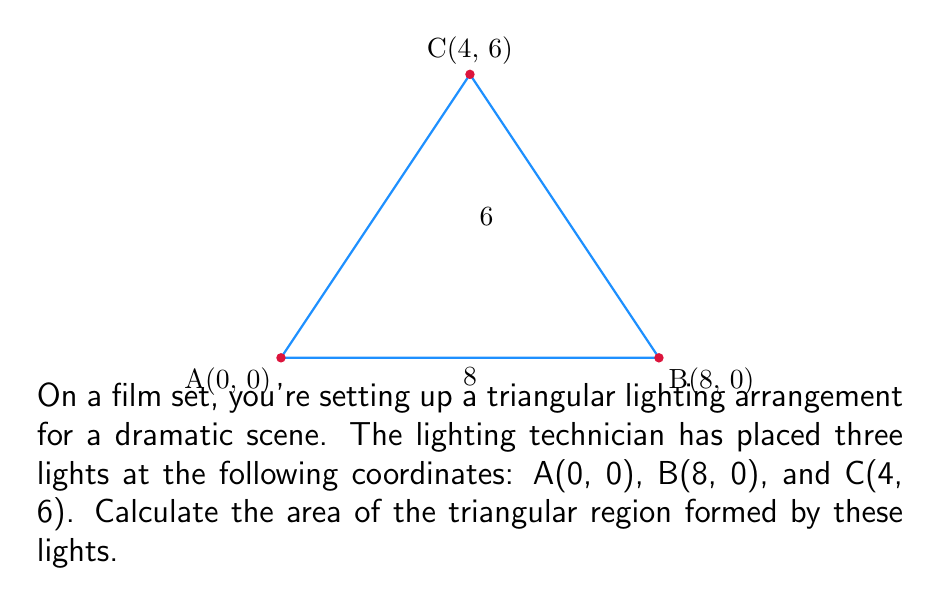Teach me how to tackle this problem. To find the area of the triangle, we can use the formula:

$$ \text{Area} = \frac{1}{2}|\text{det}(\vec{AB}, \vec{AC})| $$

Where $\vec{AB}$ and $\vec{AC}$ are vectors representing two sides of the triangle.

Step 1: Find vectors $\vec{AB}$ and $\vec{AC}$
$\vec{AB} = B - A = (8-0, 0-0) = (8, 0)$
$\vec{AC} = C - A = (4-0, 6-0) = (4, 6)$

Step 2: Calculate the determinant
$$ \text{det}(\vec{AB}, \vec{AC}) = \begin{vmatrix} 
8 & 4 \\
0 & 6
\end{vmatrix} = 8(6) - 4(0) = 48 $$

Step 3: Apply the area formula
$$ \text{Area} = \frac{1}{2}|48| = 24 $$

Therefore, the area of the triangular lighting setup is 24 square units.
Answer: 24 square units 